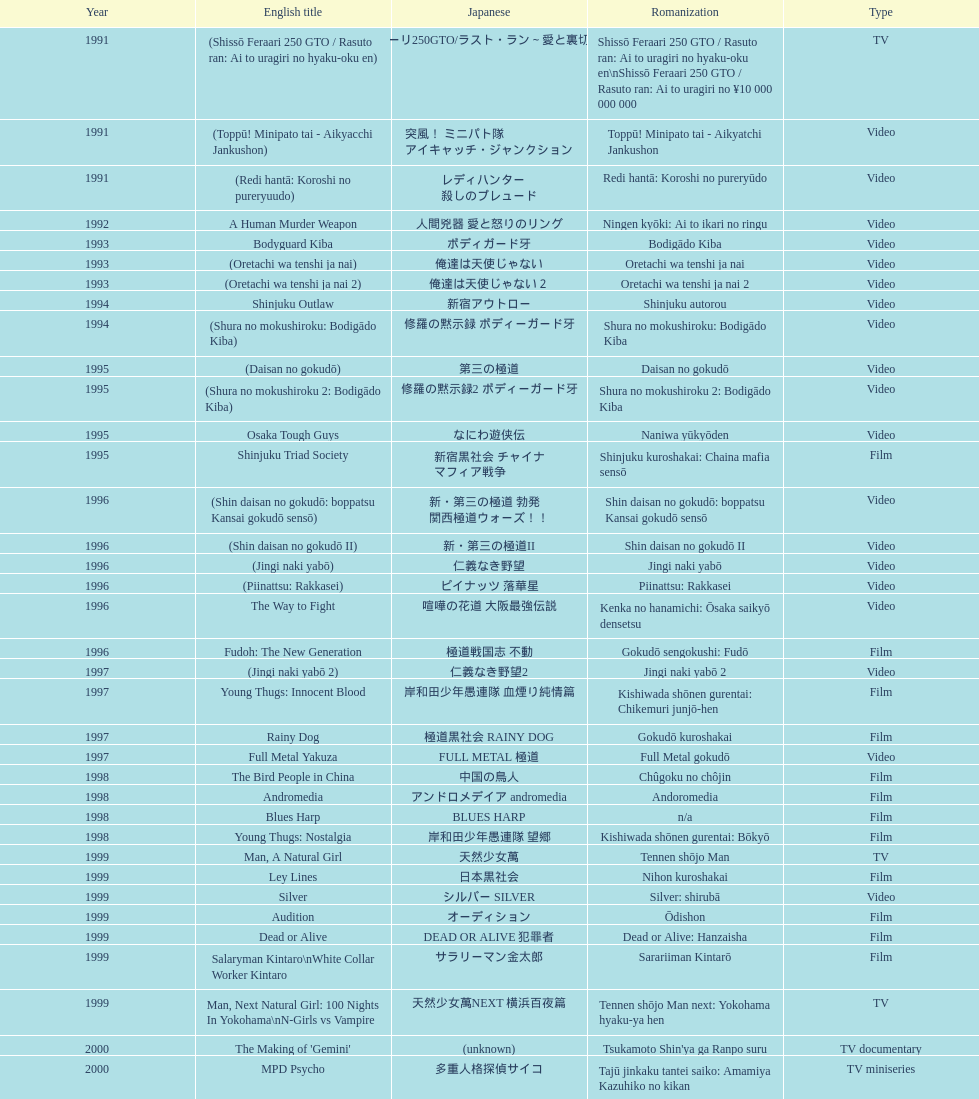I'm looking to parse the entire table for insights. Could you assist me with that? {'header': ['Year', 'English title', 'Japanese', 'Romanization', 'Type'], 'rows': [['1991', '(Shissō Feraari 250 GTO / Rasuto ran: Ai to uragiri no hyaku-oku en)', '疾走フェラーリ250GTO/ラスト・ラン～愛と裏切りの百億円', 'Shissō Feraari 250 GTO / Rasuto ran: Ai to uragiri no hyaku-oku en\\nShissō Feraari 250 GTO / Rasuto ran: Ai to uragiri no ¥10 000 000 000', 'TV'], ['1991', '(Toppū! Minipato tai - Aikyacchi Jankushon)', '突風！ ミニパト隊 アイキャッチ・ジャンクション', 'Toppū! Minipato tai - Aikyatchi Jankushon', 'Video'], ['1991', '(Redi hantā: Koroshi no pureryuudo)', 'レディハンター 殺しのプレュード', 'Redi hantā: Koroshi no pureryūdo', 'Video'], ['1992', 'A Human Murder Weapon', '人間兇器 愛と怒りのリング', 'Ningen kyōki: Ai to ikari no ringu', 'Video'], ['1993', 'Bodyguard Kiba', 'ボディガード牙', 'Bodigādo Kiba', 'Video'], ['1993', '(Oretachi wa tenshi ja nai)', '俺達は天使じゃない', 'Oretachi wa tenshi ja nai', 'Video'], ['1993', '(Oretachi wa tenshi ja nai 2)', '俺達は天使じゃない２', 'Oretachi wa tenshi ja nai 2', 'Video'], ['1994', 'Shinjuku Outlaw', '新宿アウトロー', 'Shinjuku autorou', 'Video'], ['1994', '(Shura no mokushiroku: Bodigādo Kiba)', '修羅の黙示録 ボディーガード牙', 'Shura no mokushiroku: Bodigādo Kiba', 'Video'], ['1995', '(Daisan no gokudō)', '第三の極道', 'Daisan no gokudō', 'Video'], ['1995', '(Shura no mokushiroku 2: Bodigādo Kiba)', '修羅の黙示録2 ボディーガード牙', 'Shura no mokushiroku 2: Bodigādo Kiba', 'Video'], ['1995', 'Osaka Tough Guys', 'なにわ遊侠伝', 'Naniwa yūkyōden', 'Video'], ['1995', 'Shinjuku Triad Society', '新宿黒社会 チャイナ マフィア戦争', 'Shinjuku kuroshakai: Chaina mafia sensō', 'Film'], ['1996', '(Shin daisan no gokudō: boppatsu Kansai gokudō sensō)', '新・第三の極道 勃発 関西極道ウォーズ！！', 'Shin daisan no gokudō: boppatsu Kansai gokudō sensō', 'Video'], ['1996', '(Shin daisan no gokudō II)', '新・第三の極道II', 'Shin daisan no gokudō II', 'Video'], ['1996', '(Jingi naki yabō)', '仁義なき野望', 'Jingi naki yabō', 'Video'], ['1996', '(Piinattsu: Rakkasei)', 'ピイナッツ 落華星', 'Piinattsu: Rakkasei', 'Video'], ['1996', 'The Way to Fight', '喧嘩の花道 大阪最強伝説', 'Kenka no hanamichi: Ōsaka saikyō densetsu', 'Video'], ['1996', 'Fudoh: The New Generation', '極道戦国志 不動', 'Gokudō sengokushi: Fudō', 'Film'], ['1997', '(Jingi naki yabō 2)', '仁義なき野望2', 'Jingi naki yabō 2', 'Video'], ['1997', 'Young Thugs: Innocent Blood', '岸和田少年愚連隊 血煙り純情篇', 'Kishiwada shōnen gurentai: Chikemuri junjō-hen', 'Film'], ['1997', 'Rainy Dog', '極道黒社会 RAINY DOG', 'Gokudō kuroshakai', 'Film'], ['1997', 'Full Metal Yakuza', 'FULL METAL 極道', 'Full Metal gokudō', 'Video'], ['1998', 'The Bird People in China', '中国の鳥人', 'Chûgoku no chôjin', 'Film'], ['1998', 'Andromedia', 'アンドロメデイア andromedia', 'Andoromedia', 'Film'], ['1998', 'Blues Harp', 'BLUES HARP', 'n/a', 'Film'], ['1998', 'Young Thugs: Nostalgia', '岸和田少年愚連隊 望郷', 'Kishiwada shōnen gurentai: Bōkyō', 'Film'], ['1999', 'Man, A Natural Girl', '天然少女萬', 'Tennen shōjo Man', 'TV'], ['1999', 'Ley Lines', '日本黒社会', 'Nihon kuroshakai', 'Film'], ['1999', 'Silver', 'シルバー SILVER', 'Silver: shirubā', 'Video'], ['1999', 'Audition', 'オーディション', 'Ōdishon', 'Film'], ['1999', 'Dead or Alive', 'DEAD OR ALIVE 犯罪者', 'Dead or Alive: Hanzaisha', 'Film'], ['1999', 'Salaryman Kintaro\\nWhite Collar Worker Kintaro', 'サラリーマン金太郎', 'Sarariiman Kintarō', 'Film'], ['1999', 'Man, Next Natural Girl: 100 Nights In Yokohama\\nN-Girls vs Vampire', '天然少女萬NEXT 横浜百夜篇', 'Tennen shōjo Man next: Yokohama hyaku-ya hen', 'TV'], ['2000', "The Making of 'Gemini'", '(unknown)', "Tsukamoto Shin'ya ga Ranpo suru", 'TV documentary'], ['2000', 'MPD Psycho', '多重人格探偵サイコ', 'Tajū jinkaku tantei saiko: Amamiya Kazuhiko no kikan', 'TV miniseries'], ['2000', 'The City of Lost Souls\\nThe City of Strangers\\nThe Hazard City', '漂流街 THE HAZARD CITY', 'Hyōryū-gai', 'Film'], ['2000', 'The Guys from Paradise', '天国から来た男たち', 'Tengoku kara kita otoko-tachi', 'Film'], ['2000', 'Dead or Alive 2: Birds\\nDead or Alive 2: Runaway', 'DEAD OR ALIVE 2 逃亡者', 'Dead or Alive 2: Tōbōsha', 'Film'], ['2001', '(Kikuchi-jō monogatari: sakimori-tachi no uta)', '鞠智城物語 防人たちの唄', 'Kikuchi-jō monogatari: sakimori-tachi no uta', 'Film'], ['2001', '(Zuiketsu gensō: Tonkararin yume densetsu)', '隧穴幻想 トンカラリン夢伝説', 'Zuiketsu gensō: Tonkararin yume densetsu', 'Film'], ['2001', 'Family', 'FAMILY', 'n/a', 'Film'], ['2001', 'Visitor Q', 'ビジターQ', 'Bijitā Q', 'Video'], ['2001', 'Ichi the Killer', '殺し屋1', 'Koroshiya 1', 'Film'], ['2001', 'Agitator', '荒ぶる魂たち', 'Araburu tamashii-tachi', 'Film'], ['2001', 'The Happiness of the Katakuris', 'カタクリ家の幸福', 'Katakuri-ke no kōfuku', 'Film'], ['2002', 'Dead or Alive: Final', 'DEAD OR ALIVE FINAL', 'n/a', 'Film'], ['2002', '(Onna kunishū ikki)', 'おんな 国衆一揆', 'Onna kunishū ikki', '(unknown)'], ['2002', 'Sabu', 'SABU さぶ', 'Sabu', 'TV'], ['2002', 'Graveyard of Honor', '新・仁義の墓場', 'Shin jingi no hakaba', 'Film'], ['2002', 'Shangri-La', '金融破滅ニッポン 桃源郷の人々', "Kin'yū hametsu Nippon: Tōgenkyō no hito-bito", 'Film'], ['2002', 'Pandōra', 'パンドーラ', 'Pandōra', 'Music video'], ['2002', 'Deadly Outlaw: Rekka\\nViolent Fire', '実録・安藤昇侠道（アウトロー）伝 烈火', 'Jitsuroku Andō Noboru kyōdō-den: Rekka', 'Film'], ['2002', 'Pāto-taimu tantei', 'パートタイム探偵', 'Pāto-taimu tantei', 'TV series'], ['2003', 'The Man in White', '許されざる者', 'Yurusarezaru mono', 'Film'], ['2003', 'Gozu', '極道恐怖大劇場 牛頭 GOZU', 'Gokudō kyōfu dai-gekijō: Gozu', 'Film'], ['2003', 'Yakuza Demon', '鬼哭 kikoku', 'Kikoku', 'Video'], ['2003', 'Kōshōnin', '交渉人', 'Kōshōnin', 'TV'], ['2003', "One Missed Call\\nYou've Got a Call", '着信アリ', 'Chakushin Ari', 'Film'], ['2004', 'Zebraman', 'ゼブラーマン', 'Zeburāman', 'Film'], ['2004', 'Pāto-taimu tantei 2', 'パートタイム探偵2', 'Pāto-taimu tantei 2', 'TV'], ['2004', 'Box segment in Three... Extremes', 'BOX（『美しい夜、残酷な朝』）', 'Saam gaang yi', 'Segment in feature film'], ['2004', 'Izo', 'IZO', 'IZO', 'Film'], ['2005', 'Ultraman Max', 'ウルトラマンマックス', 'Urutoraman Makkusu', 'Episodes 15 and 16 from TV tokusatsu series'], ['2005', 'The Great Yokai War', '妖怪大戦争', 'Yokai Daisenso', 'Film'], ['2006', 'Big Bang Love, Juvenile A\\n4.6 Billion Years of Love', '46億年の恋', '46-okunen no koi', 'Film'], ['2006', 'Waru', 'WARU', 'Waru', 'Film'], ['2006', 'Imprint episode from Masters of Horror', 'インプリント ～ぼっけえ、きょうてえ～', 'Inpurinto ~bokke kyote~', 'TV episode'], ['2006', 'Waru: kanketsu-hen', '', 'Waru: kanketsu-hen', 'Video'], ['2006', 'Sun Scarred', '太陽の傷', 'Taiyo no kizu', 'Film'], ['2007', 'Sukiyaki Western Django', 'スキヤキ・ウエスタン ジャンゴ', 'Sukiyaki wesutān jango', 'Film'], ['2007', 'Crows Zero', 'クローズZERO', 'Kurōzu Zero', 'Film'], ['2007', 'Like a Dragon', '龍が如く 劇場版', 'Ryu ga Gotoku Gekijōban', 'Film'], ['2007', 'Zatoichi', '座頭市', 'Zatōichi', 'Stageplay'], ['2007', 'Detective Story', '探偵物語', 'Tantei monogatari', 'Film'], ['2008', "God's Puzzle", '神様のパズル', 'Kamisama no pazuru', 'Film'], ['2008', 'K-tai Investigator 7', 'ケータイ捜査官7', 'Keitai Sōsakan 7', 'TV'], ['2009', 'Yatterman', 'ヤッターマン', 'Yattaaman', 'Film'], ['2009', 'Crows Zero 2', 'クローズZERO 2', 'Kurōzu Zero 2', 'Film'], ['2010', 'Thirteen Assassins', '十三人の刺客', 'Jûsan-nin no shikaku', 'Film'], ['2010', 'Zebraman 2: Attack on Zebra City', 'ゼブラーマン -ゼブラシティの逆襲', 'Zeburāman -Zebura Shiti no Gyakushū', 'Film'], ['2011', 'Ninja Kids!!!', '忍たま乱太郎', 'Nintama Rantarō', 'Film'], ['2011', 'Hara-Kiri: Death of a Samurai', '一命', 'Ichimei', 'Film'], ['2012', 'Ace Attorney', '逆転裁判', 'Gyakuten Saiban', 'Film'], ['2012', "For Love's Sake", '愛と誠', 'Ai to makoto', 'Film'], ['2012', 'Lesson of the Evil', '悪の教典', 'Aku no Kyōten', 'Film'], ['2013', 'Shield of Straw', '藁の楯', 'Wara no Tate', 'Film'], ['2013', 'The Mole Song: Undercover Agent Reiji', '土竜の唄\u3000潜入捜査官 REIJI', 'Mogura no uta – sennyu sosakan: Reiji', 'Film']]} Were more air on tv or video? Video. 